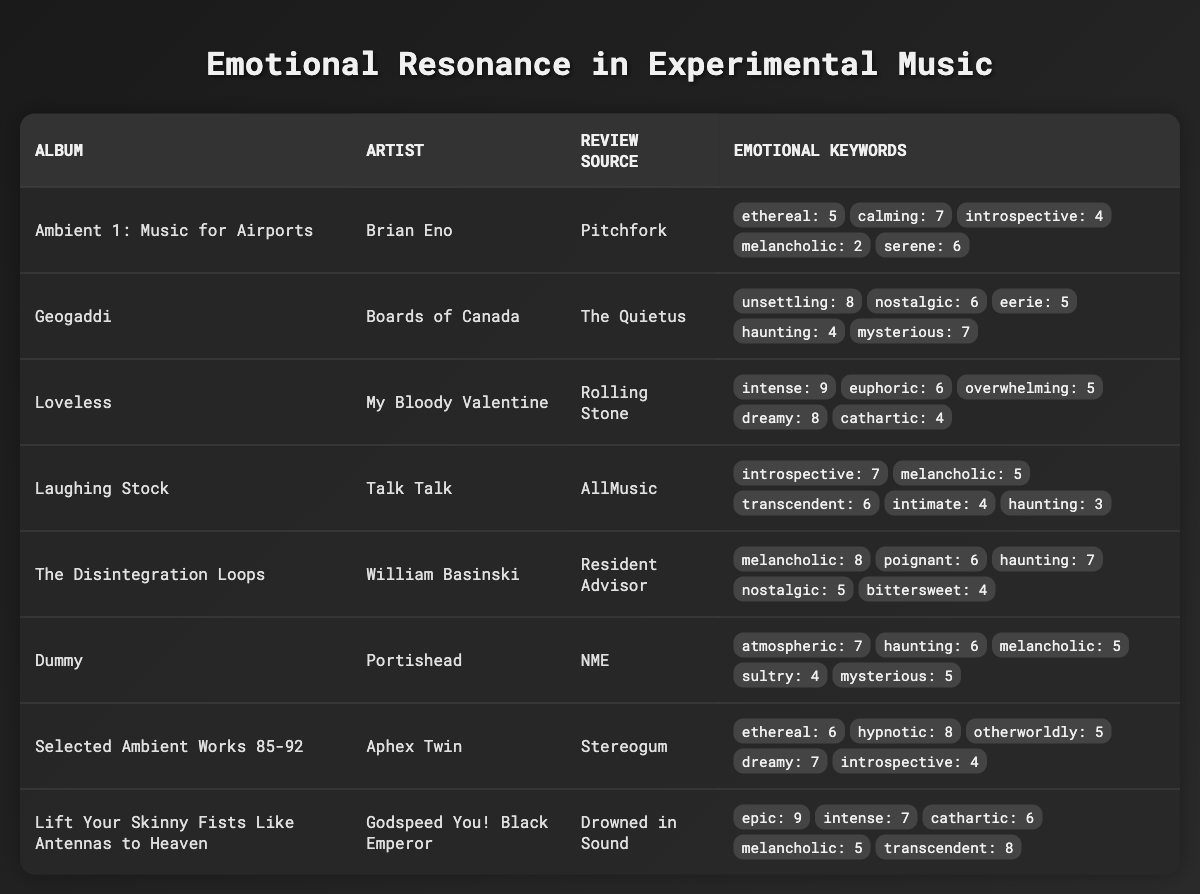What is the most frequently mentioned emotional keyword in album reviews? By checking the emotional keyword counts in the table, "haunting" appears most frequently, with a total of 6 mentions across several albums.
Answer: haunting Which album has the highest count for the keyword "intense"? "Loveless" by My Bloody Valentine has the highest count for "intense," which is 9.
Answer: Loveless What is the total count of emotional keywords for "The Disintegration Loops"? The emotional keywords for "The Disintegration Loops" add up to 30 (8 + 6 + 7 + 5 + 4).
Answer: 30 Is the album "Dummy" considered melancholic based on the reviews? Yes, "Dummy" includes "melancholic" in its emotional keywords with a count of 5, indicating it is considered melancholic.
Answer: Yes Which album is described as both epic and transcendent? "Lift Your Skinny Fists Like Antennas to Heaven" is described using both "epic" (9) and "transcendent" (8) emotional keywords.
Answer: Lift Your Skinny Fists Like Antennas to Heaven What are the total occurrences of dreamy keywords across all albums? The total count of the keyword "dreamy" across all albums is 15 (8 from "Loveless," 7 from "Selected Ambient Works 85-92").
Answer: 15 Among all albums, which has the lowest count for the keyword "cathartic"? "Loveless" has the lowest count for the keyword "cathartic," with a count of 4.
Answer: Loveless Which artist has the highest total emotional keyword counts across their albums? By summing the counts for each album, "Godspeed You! Black Emperor" has the highest total emotional keyword count of 30 (9 + 7 + 6 + 5 + 8).
Answer: Godspeed You! Black Emperor What is the combined count for "melancholic" and "nostalgic"? The combined count for "melancholic" (8 in "The Disintegration Loops" + 5 in "Dummy" + 5 in "Laughing Stock") and "nostalgic" (6 in "Geogaddi") totals to 24.
Answer: 24 Does any album mention the keyword "unsettling"? Yes, "Geogaddi" mentions the keyword "unsettling" with a count of 8.
Answer: Yes 